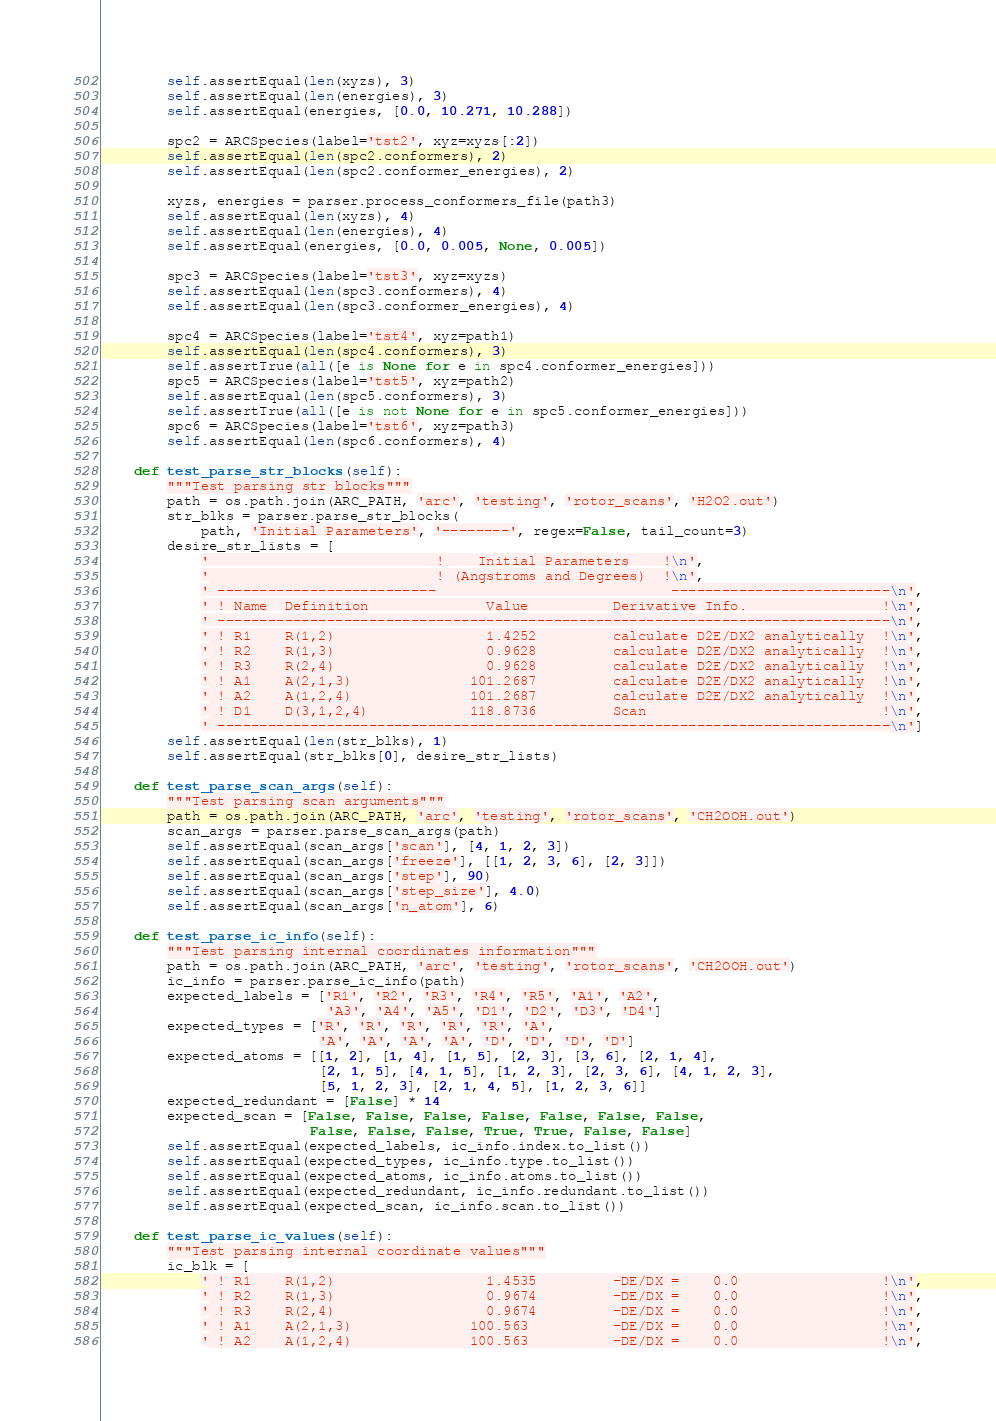<code> <loc_0><loc_0><loc_500><loc_500><_Python_>        self.assertEqual(len(xyzs), 3)
        self.assertEqual(len(energies), 3)
        self.assertEqual(energies, [0.0, 10.271, 10.288])

        spc2 = ARCSpecies(label='tst2', xyz=xyzs[:2])
        self.assertEqual(len(spc2.conformers), 2)
        self.assertEqual(len(spc2.conformer_energies), 2)

        xyzs, energies = parser.process_conformers_file(path3)
        self.assertEqual(len(xyzs), 4)
        self.assertEqual(len(energies), 4)
        self.assertEqual(energies, [0.0, 0.005, None, 0.005])

        spc3 = ARCSpecies(label='tst3', xyz=xyzs)
        self.assertEqual(len(spc3.conformers), 4)
        self.assertEqual(len(spc3.conformer_energies), 4)

        spc4 = ARCSpecies(label='tst4', xyz=path1)
        self.assertEqual(len(spc4.conformers), 3)
        self.assertTrue(all([e is None for e in spc4.conformer_energies]))
        spc5 = ARCSpecies(label='tst5', xyz=path2)
        self.assertEqual(len(spc5.conformers), 3)
        self.assertTrue(all([e is not None for e in spc5.conformer_energies]))
        spc6 = ARCSpecies(label='tst6', xyz=path3)
        self.assertEqual(len(spc6.conformers), 4)

    def test_parse_str_blocks(self):
        """Test parsing str blocks"""
        path = os.path.join(ARC_PATH, 'arc', 'testing', 'rotor_scans', 'H2O2.out')
        str_blks = parser.parse_str_blocks(
            path, 'Initial Parameters', '--------', regex=False, tail_count=3)
        desire_str_lists = [
            '                           !    Initial Parameters    !\n',
            '                           ! (Angstroms and Degrees)  !\n',
            ' --------------------------                            --------------------------\n',
            ' ! Name  Definition              Value          Derivative Info.                !\n',
            ' --------------------------------------------------------------------------------\n',
            ' ! R1    R(1,2)                  1.4252         calculate D2E/DX2 analytically  !\n',
            ' ! R2    R(1,3)                  0.9628         calculate D2E/DX2 analytically  !\n',
            ' ! R3    R(2,4)                  0.9628         calculate D2E/DX2 analytically  !\n',
            ' ! A1    A(2,1,3)              101.2687         calculate D2E/DX2 analytically  !\n',
            ' ! A2    A(1,2,4)              101.2687         calculate D2E/DX2 analytically  !\n',
            ' ! D1    D(3,1,2,4)            118.8736         Scan                            !\n',
            ' --------------------------------------------------------------------------------\n']
        self.assertEqual(len(str_blks), 1)
        self.assertEqual(str_blks[0], desire_str_lists)

    def test_parse_scan_args(self):
        """Test parsing scan arguments"""
        path = os.path.join(ARC_PATH, 'arc', 'testing', 'rotor_scans', 'CH2OOH.out')
        scan_args = parser.parse_scan_args(path)
        self.assertEqual(scan_args['scan'], [4, 1, 2, 3])
        self.assertEqual(scan_args['freeze'], [[1, 2, 3, 6], [2, 3]])
        self.assertEqual(scan_args['step'], 90)
        self.assertEqual(scan_args['step_size'], 4.0)
        self.assertEqual(scan_args['n_atom'], 6)

    def test_parse_ic_info(self):
        """Test parsing internal coordinates information"""
        path = os.path.join(ARC_PATH, 'arc', 'testing', 'rotor_scans', 'CH2OOH.out')
        ic_info = parser.parse_ic_info(path)
        expected_labels = ['R1', 'R2', 'R3', 'R4', 'R5', 'A1', 'A2',
                           'A3', 'A4', 'A5', 'D1', 'D2', 'D3', 'D4']
        expected_types = ['R', 'R', 'R', 'R', 'R', 'A',
                          'A', 'A', 'A', 'A', 'D', 'D', 'D', 'D']
        expected_atoms = [[1, 2], [1, 4], [1, 5], [2, 3], [3, 6], [2, 1, 4],
                          [2, 1, 5], [4, 1, 5], [1, 2, 3], [2, 3, 6], [4, 1, 2, 3],
                          [5, 1, 2, 3], [2, 1, 4, 5], [1, 2, 3, 6]]
        expected_redundant = [False] * 14
        expected_scan = [False, False, False, False, False, False, False,
                         False, False, False, True, True, False, False]
        self.assertEqual(expected_labels, ic_info.index.to_list())
        self.assertEqual(expected_types, ic_info.type.to_list())
        self.assertEqual(expected_atoms, ic_info.atoms.to_list())
        self.assertEqual(expected_redundant, ic_info.redundant.to_list())
        self.assertEqual(expected_scan, ic_info.scan.to_list())

    def test_parse_ic_values(self):
        """Test parsing internal coordinate values"""
        ic_blk = [
            ' ! R1    R(1,2)                  1.4535         -DE/DX =    0.0                 !\n',
            ' ! R2    R(1,3)                  0.9674         -DE/DX =    0.0                 !\n',
            ' ! R3    R(2,4)                  0.9674         -DE/DX =    0.0                 !\n',
            ' ! A1    A(2,1,3)              100.563          -DE/DX =    0.0                 !\n',
            ' ! A2    A(1,2,4)              100.563          -DE/DX =    0.0                 !\n',</code> 